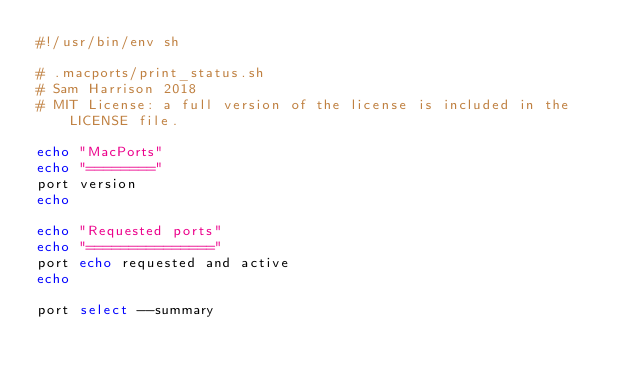Convert code to text. <code><loc_0><loc_0><loc_500><loc_500><_Bash_>#!/usr/bin/env sh

# .macports/print_status.sh
# Sam Harrison 2018
# MIT License: a full version of the license is included in the LICENSE file.

echo "MacPorts"
echo "========"
port version
echo

echo "Requested ports"
echo "==============="
port echo requested and active
echo

port select --summary
</code> 